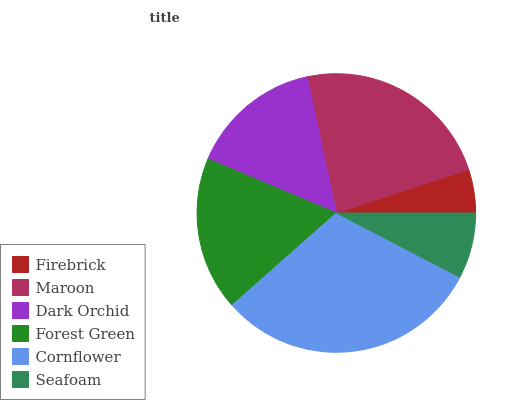Is Firebrick the minimum?
Answer yes or no. Yes. Is Cornflower the maximum?
Answer yes or no. Yes. Is Maroon the minimum?
Answer yes or no. No. Is Maroon the maximum?
Answer yes or no. No. Is Maroon greater than Firebrick?
Answer yes or no. Yes. Is Firebrick less than Maroon?
Answer yes or no. Yes. Is Firebrick greater than Maroon?
Answer yes or no. No. Is Maroon less than Firebrick?
Answer yes or no. No. Is Forest Green the high median?
Answer yes or no. Yes. Is Dark Orchid the low median?
Answer yes or no. Yes. Is Cornflower the high median?
Answer yes or no. No. Is Seafoam the low median?
Answer yes or no. No. 